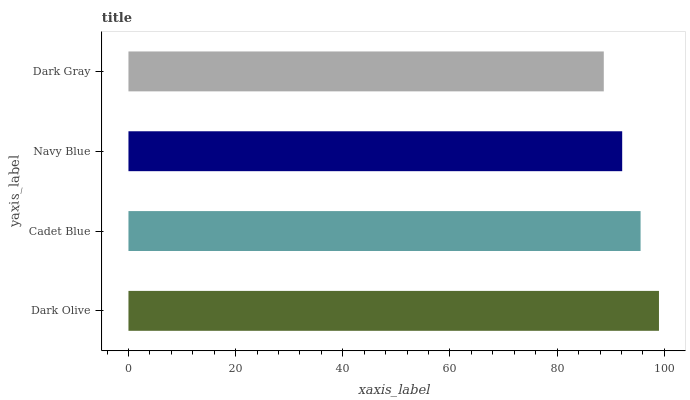Is Dark Gray the minimum?
Answer yes or no. Yes. Is Dark Olive the maximum?
Answer yes or no. Yes. Is Cadet Blue the minimum?
Answer yes or no. No. Is Cadet Blue the maximum?
Answer yes or no. No. Is Dark Olive greater than Cadet Blue?
Answer yes or no. Yes. Is Cadet Blue less than Dark Olive?
Answer yes or no. Yes. Is Cadet Blue greater than Dark Olive?
Answer yes or no. No. Is Dark Olive less than Cadet Blue?
Answer yes or no. No. Is Cadet Blue the high median?
Answer yes or no. Yes. Is Navy Blue the low median?
Answer yes or no. Yes. Is Dark Gray the high median?
Answer yes or no. No. Is Dark Gray the low median?
Answer yes or no. No. 